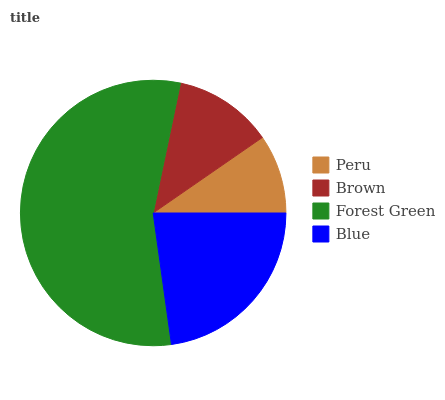Is Peru the minimum?
Answer yes or no. Yes. Is Forest Green the maximum?
Answer yes or no. Yes. Is Brown the minimum?
Answer yes or no. No. Is Brown the maximum?
Answer yes or no. No. Is Brown greater than Peru?
Answer yes or no. Yes. Is Peru less than Brown?
Answer yes or no. Yes. Is Peru greater than Brown?
Answer yes or no. No. Is Brown less than Peru?
Answer yes or no. No. Is Blue the high median?
Answer yes or no. Yes. Is Brown the low median?
Answer yes or no. Yes. Is Forest Green the high median?
Answer yes or no. No. Is Forest Green the low median?
Answer yes or no. No. 